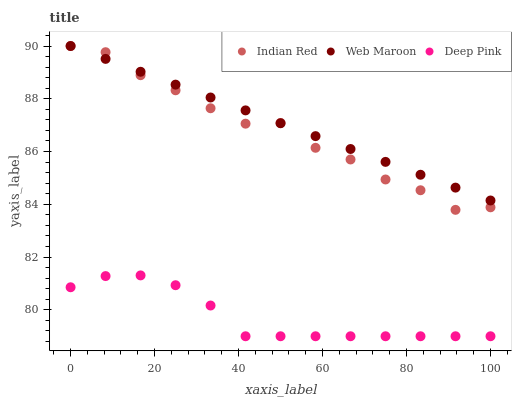Does Deep Pink have the minimum area under the curve?
Answer yes or no. Yes. Does Web Maroon have the maximum area under the curve?
Answer yes or no. Yes. Does Indian Red have the minimum area under the curve?
Answer yes or no. No. Does Indian Red have the maximum area under the curve?
Answer yes or no. No. Is Web Maroon the smoothest?
Answer yes or no. Yes. Is Indian Red the roughest?
Answer yes or no. Yes. Is Indian Red the smoothest?
Answer yes or no. No. Is Web Maroon the roughest?
Answer yes or no. No. Does Deep Pink have the lowest value?
Answer yes or no. Yes. Does Indian Red have the lowest value?
Answer yes or no. No. Does Indian Red have the highest value?
Answer yes or no. Yes. Is Deep Pink less than Indian Red?
Answer yes or no. Yes. Is Web Maroon greater than Deep Pink?
Answer yes or no. Yes. Does Web Maroon intersect Indian Red?
Answer yes or no. Yes. Is Web Maroon less than Indian Red?
Answer yes or no. No. Is Web Maroon greater than Indian Red?
Answer yes or no. No. Does Deep Pink intersect Indian Red?
Answer yes or no. No. 